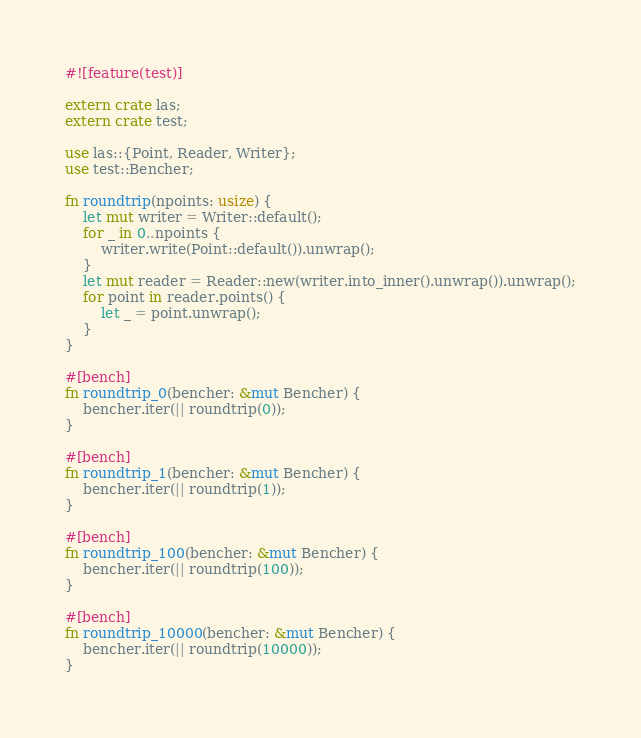<code> <loc_0><loc_0><loc_500><loc_500><_Rust_>#![feature(test)]

extern crate las;
extern crate test;

use las::{Point, Reader, Writer};
use test::Bencher;

fn roundtrip(npoints: usize) {
    let mut writer = Writer::default();
    for _ in 0..npoints {
        writer.write(Point::default()).unwrap();
    }
    let mut reader = Reader::new(writer.into_inner().unwrap()).unwrap();
    for point in reader.points() {
        let _ = point.unwrap();
    }
}

#[bench]
fn roundtrip_0(bencher: &mut Bencher) {
    bencher.iter(|| roundtrip(0));
}

#[bench]
fn roundtrip_1(bencher: &mut Bencher) {
    bencher.iter(|| roundtrip(1));
}

#[bench]
fn roundtrip_100(bencher: &mut Bencher) {
    bencher.iter(|| roundtrip(100));
}

#[bench]
fn roundtrip_10000(bencher: &mut Bencher) {
    bencher.iter(|| roundtrip(10000));
}
</code> 